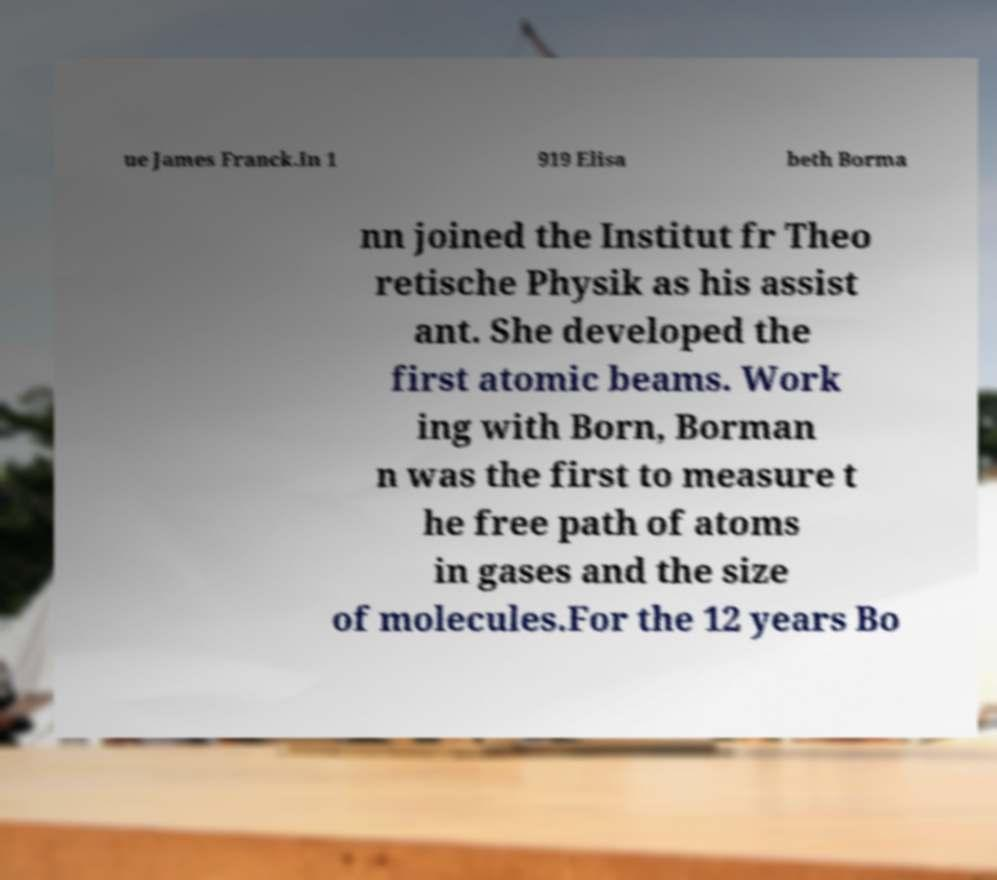Please read and relay the text visible in this image. What does it say? ue James Franck.In 1 919 Elisa beth Borma nn joined the Institut fr Theo retische Physik as his assist ant. She developed the first atomic beams. Work ing with Born, Borman n was the first to measure t he free path of atoms in gases and the size of molecules.For the 12 years Bo 